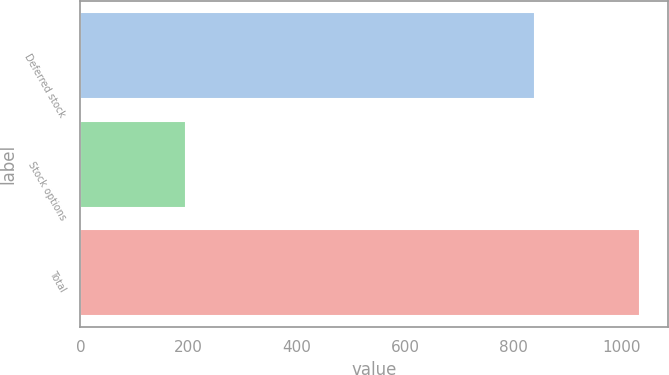Convert chart to OTSL. <chart><loc_0><loc_0><loc_500><loc_500><bar_chart><fcel>Deferred stock<fcel>Stock options<fcel>Total<nl><fcel>839<fcel>195<fcel>1034<nl></chart> 